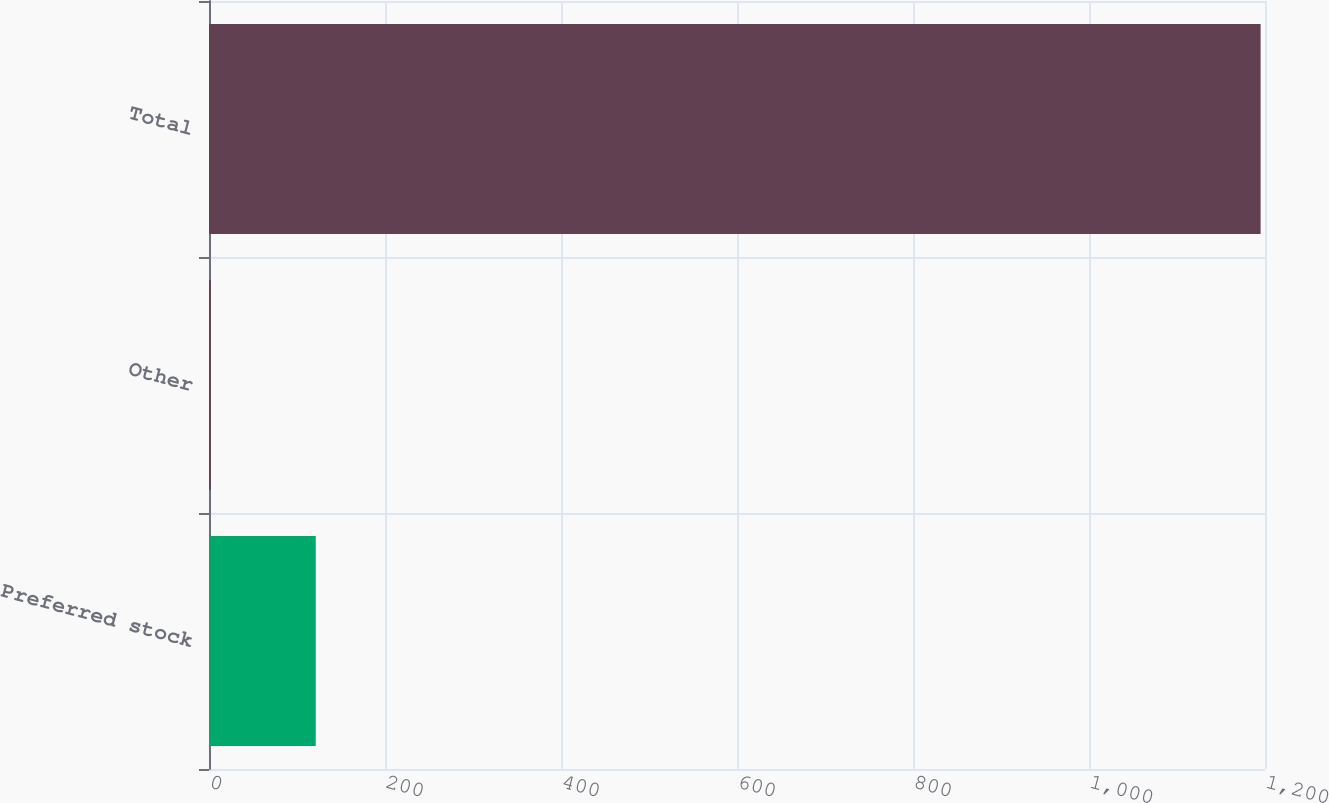Convert chart to OTSL. <chart><loc_0><loc_0><loc_500><loc_500><bar_chart><fcel>Preferred stock<fcel>Other<fcel>Total<nl><fcel>121.3<fcel>2<fcel>1195<nl></chart> 